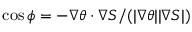<formula> <loc_0><loc_0><loc_500><loc_500>\cos { \phi } = - \nabla \theta \cdot \nabla S / ( | \nabla \theta | | \nabla S | )</formula> 